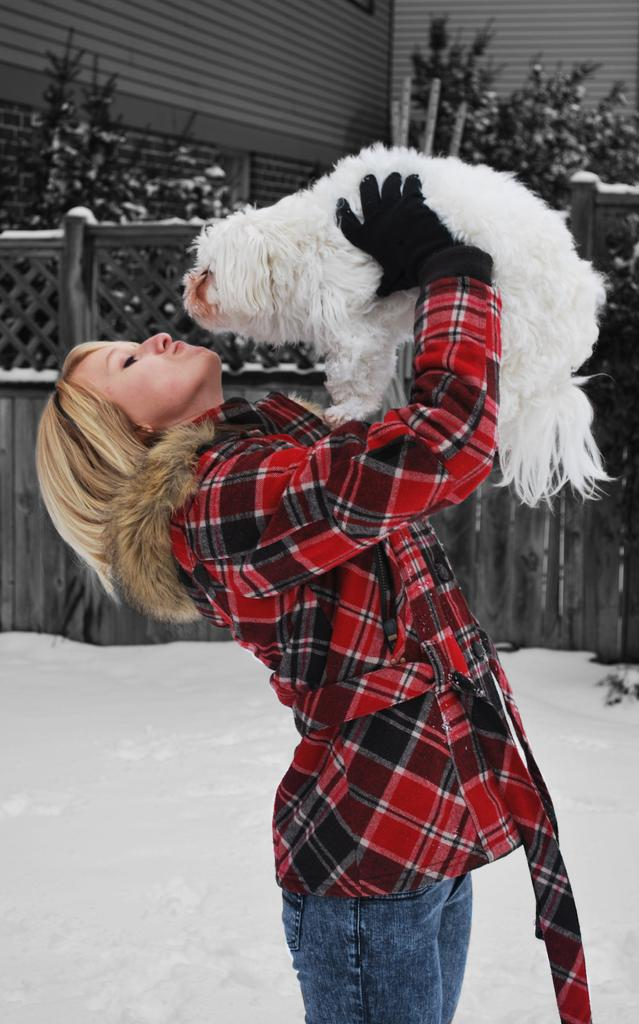Who is present in the image? There is a woman in the image. What is the woman holding in her hand? The woman is holding an animal in her hand. What is the weather like in the image? There is snow around in the image, indicating a cold environment. What type of fencing can be seen in the image? There is wooden fencing in the image. What other natural elements are present in the image? There are trees in the image. What type of summer clothing is the woman wearing in the image? The image does not depict a summer scene, as there is snow around, so it is unlikely that the woman is wearing summer clothing. 